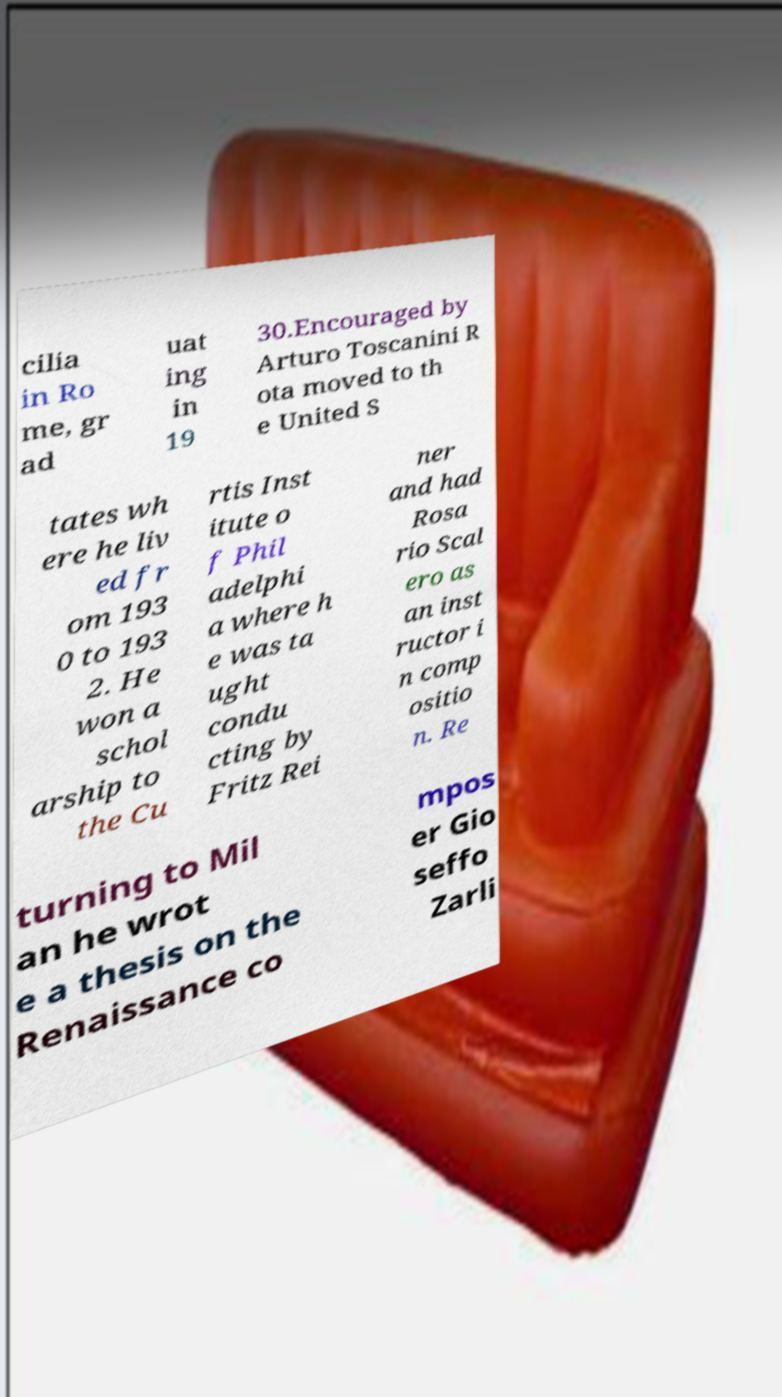Can you read and provide the text displayed in the image?This photo seems to have some interesting text. Can you extract and type it out for me? cilia in Ro me, gr ad uat ing in 19 30.Encouraged by Arturo Toscanini R ota moved to th e United S tates wh ere he liv ed fr om 193 0 to 193 2. He won a schol arship to the Cu rtis Inst itute o f Phil adelphi a where h e was ta ught condu cting by Fritz Rei ner and had Rosa rio Scal ero as an inst ructor i n comp ositio n. Re turning to Mil an he wrot e a thesis on the Renaissance co mpos er Gio seffo Zarli 